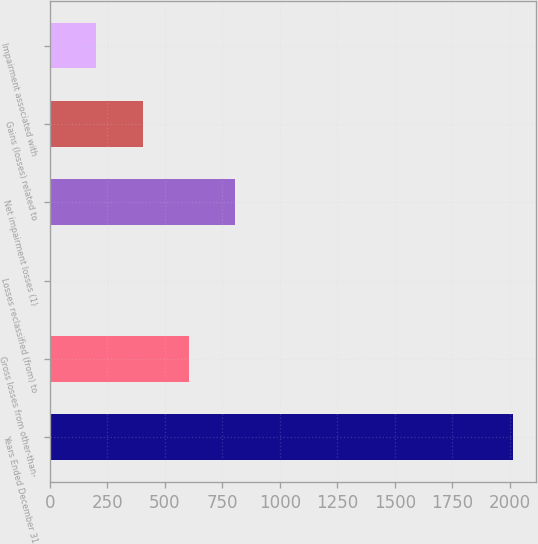<chart> <loc_0><loc_0><loc_500><loc_500><bar_chart><fcel>Years Ended December 31<fcel>Gross losses from other-than-<fcel>Losses reclassified (from) to<fcel>Net impairment losses (1)<fcel>Gains (losses) related to<fcel>Impairment associated with<nl><fcel>2013<fcel>605.3<fcel>2<fcel>806.4<fcel>404.2<fcel>203.1<nl></chart> 